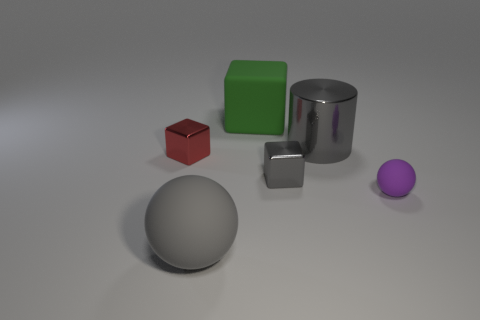What is the size of the other rubber thing that is the same shape as the tiny matte thing?
Ensure brevity in your answer.  Large. There is a big gray object on the right side of the matte thing behind the ball right of the large gray rubber ball; what is its material?
Keep it short and to the point. Metal. There is a big gray thing that is behind the small red metal thing; what shape is it?
Make the answer very short. Cylinder. There is another block that is the same material as the red block; what size is it?
Provide a succinct answer. Small. What number of green things have the same shape as the small red shiny thing?
Keep it short and to the point. 1. There is a big matte object in front of the purple sphere; is its color the same as the big metallic cylinder?
Your response must be concise. Yes. How many big gray cylinders are on the left side of the sphere that is left of the matte sphere right of the green thing?
Your answer should be compact. 0. How many objects are both behind the purple rubber object and in front of the green rubber thing?
Make the answer very short. 3. There is a big shiny object that is the same color as the large sphere; what is its shape?
Ensure brevity in your answer.  Cylinder. Is there anything else that is made of the same material as the tiny gray thing?
Offer a terse response. Yes. 